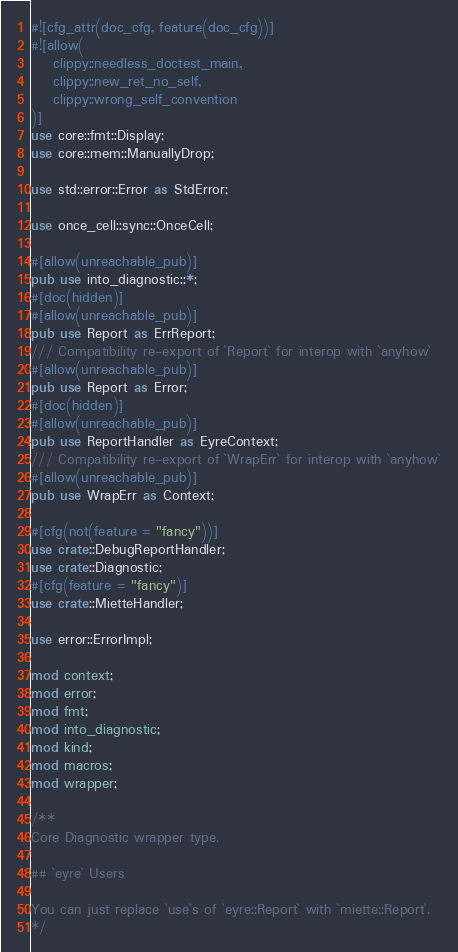Convert code to text. <code><loc_0><loc_0><loc_500><loc_500><_Rust_>#![cfg_attr(doc_cfg, feature(doc_cfg))]
#![allow(
    clippy::needless_doctest_main,
    clippy::new_ret_no_self,
    clippy::wrong_self_convention
)]
use core::fmt::Display;
use core::mem::ManuallyDrop;

use std::error::Error as StdError;

use once_cell::sync::OnceCell;

#[allow(unreachable_pub)]
pub use into_diagnostic::*;
#[doc(hidden)]
#[allow(unreachable_pub)]
pub use Report as ErrReport;
/// Compatibility re-export of `Report` for interop with `anyhow`
#[allow(unreachable_pub)]
pub use Report as Error;
#[doc(hidden)]
#[allow(unreachable_pub)]
pub use ReportHandler as EyreContext;
/// Compatibility re-export of `WrapErr` for interop with `anyhow`
#[allow(unreachable_pub)]
pub use WrapErr as Context;

#[cfg(not(feature = "fancy"))]
use crate::DebugReportHandler;
use crate::Diagnostic;
#[cfg(feature = "fancy")]
use crate::MietteHandler;

use error::ErrorImpl;

mod context;
mod error;
mod fmt;
mod into_diagnostic;
mod kind;
mod macros;
mod wrapper;

/**
Core Diagnostic wrapper type.

## `eyre` Users

You can just replace `use`s of `eyre::Report` with `miette::Report`.
*/</code> 